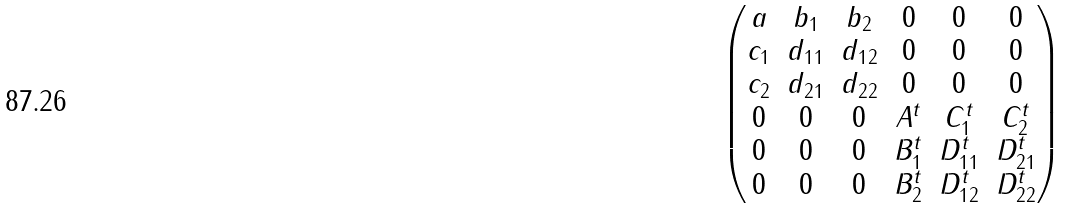<formula> <loc_0><loc_0><loc_500><loc_500>\begin{pmatrix} a & b _ { 1 } & b _ { 2 } & 0 & 0 & 0 \\ c _ { 1 } & d _ { 1 1 } & d _ { 1 2 } & 0 & 0 & 0 \\ c _ { 2 } & d _ { 2 1 } & d _ { 2 2 } & 0 & 0 & 0 \\ 0 & 0 & 0 & A ^ { t } & C ^ { t } _ { 1 } & C ^ { t } _ { 2 } \\ 0 & 0 & 0 & B ^ { t } _ { 1 } & D ^ { t } _ { 1 1 } & D ^ { t } _ { 2 1 } \\ 0 & 0 & 0 & B ^ { t } _ { 2 } & D ^ { t } _ { 1 2 } & D ^ { t } _ { 2 2 } \\ \end{pmatrix}</formula> 